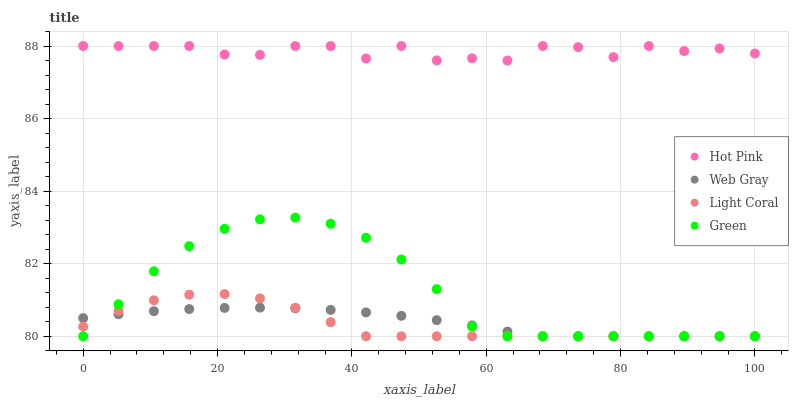Does Light Coral have the minimum area under the curve?
Answer yes or no. Yes. Does Hot Pink have the maximum area under the curve?
Answer yes or no. Yes. Does Green have the minimum area under the curve?
Answer yes or no. No. Does Green have the maximum area under the curve?
Answer yes or no. No. Is Web Gray the smoothest?
Answer yes or no. Yes. Is Hot Pink the roughest?
Answer yes or no. Yes. Is Green the smoothest?
Answer yes or no. No. Is Green the roughest?
Answer yes or no. No. Does Light Coral have the lowest value?
Answer yes or no. Yes. Does Hot Pink have the lowest value?
Answer yes or no. No. Does Hot Pink have the highest value?
Answer yes or no. Yes. Does Green have the highest value?
Answer yes or no. No. Is Light Coral less than Hot Pink?
Answer yes or no. Yes. Is Hot Pink greater than Light Coral?
Answer yes or no. Yes. Does Web Gray intersect Light Coral?
Answer yes or no. Yes. Is Web Gray less than Light Coral?
Answer yes or no. No. Is Web Gray greater than Light Coral?
Answer yes or no. No. Does Light Coral intersect Hot Pink?
Answer yes or no. No. 